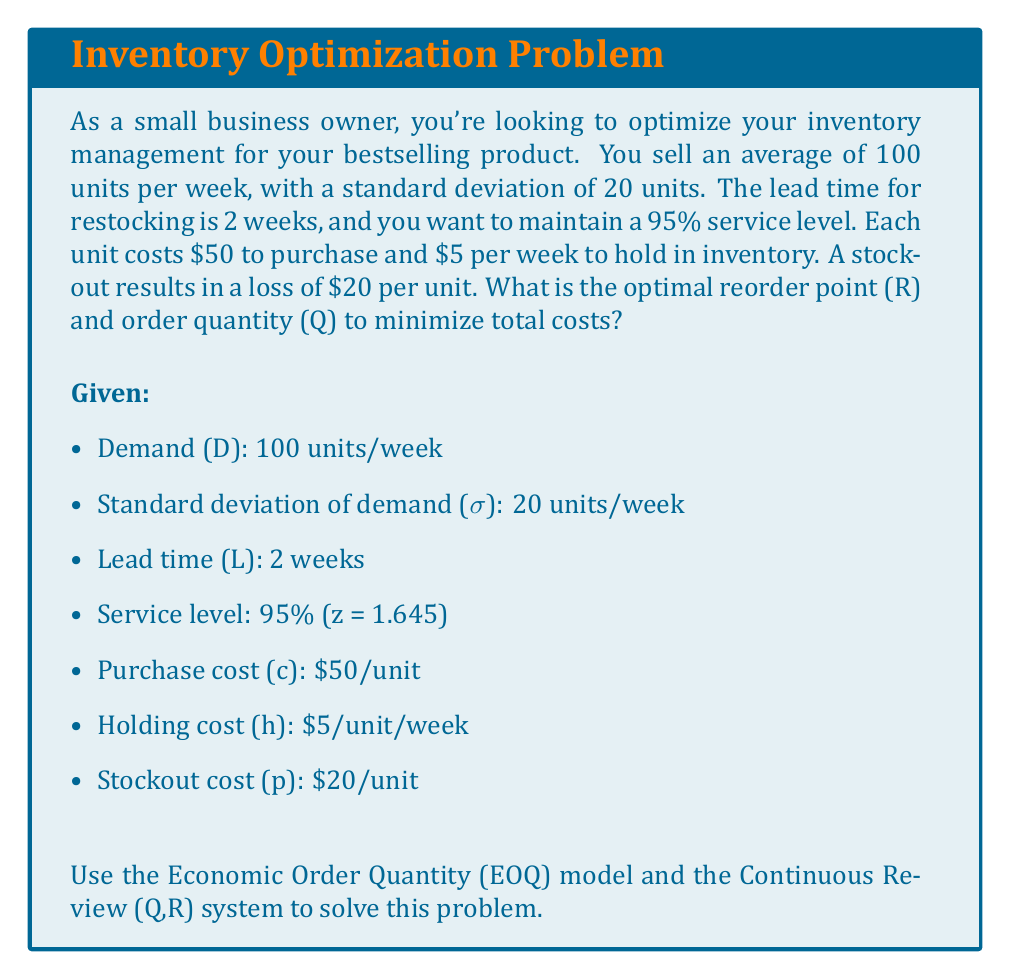Help me with this question. Let's solve this problem step by step:

1. Calculate the Economic Order Quantity (EOQ):
   $$Q^* = \sqrt{\frac{2DS}{h}}$$
   Where D is annual demand, S is fixed order cost (assumed to be $100), and h is annual holding cost.
   
   Annual demand = 100 units/week * 52 weeks = 5200 units/year
   Annual holding cost = $5/unit/week * 52 weeks = $260/unit/year
   
   $$Q^* = \sqrt{\frac{2 * 5200 * 100}{260}} \approx 200 \text{ units}$$

2. Calculate the safety stock (SS):
   $$SS = z\sigma\sqrt{L}$$
   Where z is the z-score for 95% service level (1.645), σ is the standard deviation of weekly demand, and L is lead time in weeks.
   
   $$SS = 1.645 * 20 * \sqrt{2} \approx 47 \text{ units}$$

3. Calculate the Reorder Point (R):
   $$R = \mu L + SS$$
   Where μ is the average weekly demand and L is lead time in weeks.
   
   $$R = (100 * 2) + 47 = 247 \text{ units}$$

4. Verify and adjust Q if necessary:
   The optimal Q should satisfy:
   $$\frac{h}{p+h} \geq P(X > R)$$
   Where P(X > R) is the probability of stockout.
   
   In this case, $\frac{h}{p+h} = \frac{5}{20+5} = 0.2$
   
   The current service level is 95%, which means P(X > R) = 0.05 < 0.2
   
   Therefore, our calculated Q and R are optimal.

5. Calculate total annual cost:
   Annual ordering cost = $\frac{D}{Q}S = \frac{5200}{200} * 100 = $2,600$
   Annual holding cost = $\frac{Q}{2}h + SS * h = \frac{200}{2} * 260 + 47 * 260 = $38,220$
   Annual stockout cost (approximation) = $pD(1-0.95) = 20 * 5200 * 0.05 = $5,200$
   
   Total annual cost = $2,600 + $38,220 + $5,200 = $46,020$
Answer: Optimal Reorder Point (R) = 247 units, Optimal Order Quantity (Q) = 200 units 